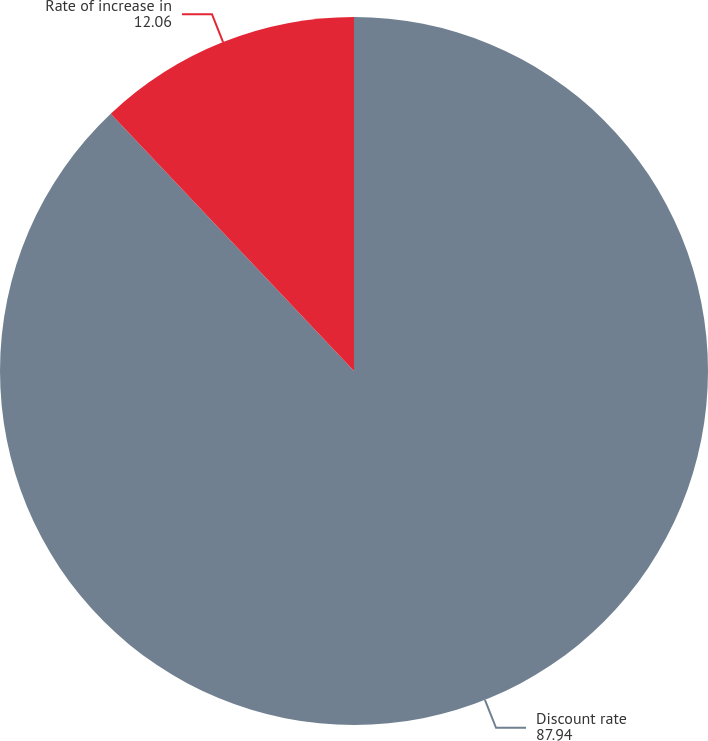Convert chart to OTSL. <chart><loc_0><loc_0><loc_500><loc_500><pie_chart><fcel>Discount rate<fcel>Rate of increase in<nl><fcel>87.94%<fcel>12.06%<nl></chart> 